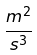Convert formula to latex. <formula><loc_0><loc_0><loc_500><loc_500>\frac { m ^ { 2 } } { s ^ { 3 } }</formula> 